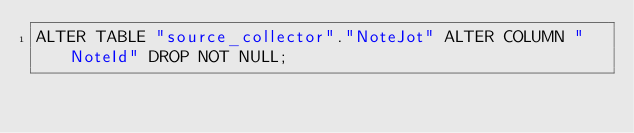<code> <loc_0><loc_0><loc_500><loc_500><_SQL_>ALTER TABLE "source_collector"."NoteJot" ALTER COLUMN "NoteId" DROP NOT NULL;
</code> 